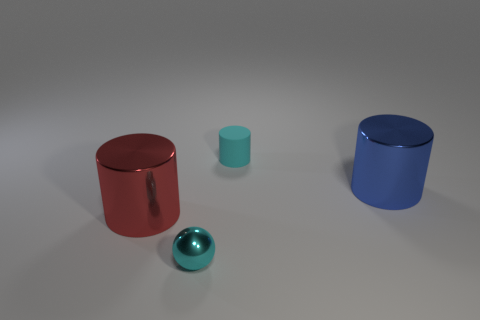There is a large metal object to the right of the large cylinder left of the big cylinder that is right of the small metallic object; what is its color?
Ensure brevity in your answer.  Blue. There is a small object that is in front of the tiny rubber thing; is it the same color as the tiny thing that is behind the big red metal object?
Your response must be concise. Yes. What is the shape of the tiny cyan thing that is in front of the cylinder left of the small rubber object?
Your answer should be compact. Sphere. Are there any red shiny cylinders that have the same size as the blue shiny thing?
Ensure brevity in your answer.  Yes. How many other big objects are the same shape as the large red object?
Your answer should be compact. 1. Are there the same number of large red metal cylinders that are right of the rubber cylinder and large red cylinders in front of the small cyan sphere?
Your answer should be compact. Yes. Are any brown cubes visible?
Your response must be concise. No. There is a thing on the right side of the cyan object that is behind the big cylinder that is right of the ball; what size is it?
Your response must be concise. Large. What shape is the red object that is the same size as the blue shiny thing?
Give a very brief answer. Cylinder. Is there any other thing that is made of the same material as the small cyan cylinder?
Your answer should be compact. No. 